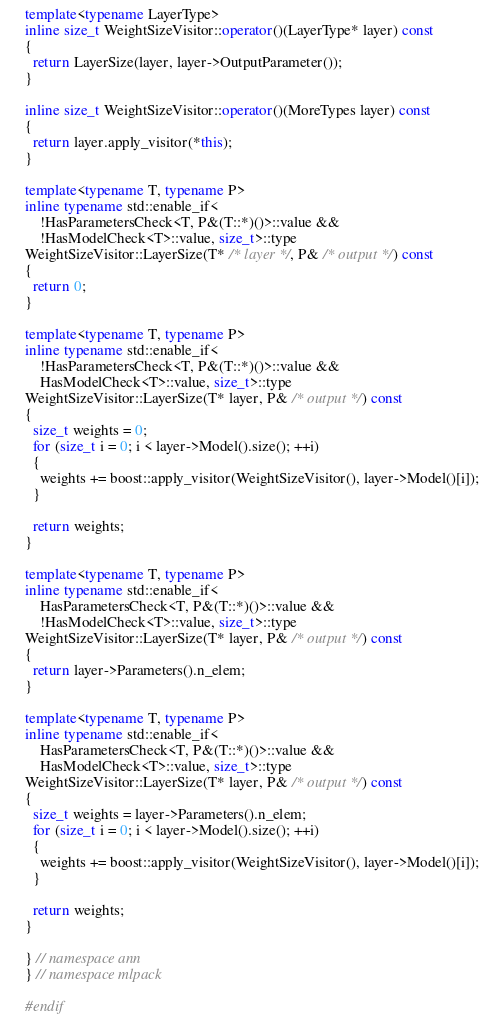<code> <loc_0><loc_0><loc_500><loc_500><_C++_>template<typename LayerType>
inline size_t WeightSizeVisitor::operator()(LayerType* layer) const
{
  return LayerSize(layer, layer->OutputParameter());
}

inline size_t WeightSizeVisitor::operator()(MoreTypes layer) const
{
  return layer.apply_visitor(*this);
}

template<typename T, typename P>
inline typename std::enable_if<
    !HasParametersCheck<T, P&(T::*)()>::value &&
    !HasModelCheck<T>::value, size_t>::type
WeightSizeVisitor::LayerSize(T* /* layer */, P& /* output */) const
{
  return 0;
}

template<typename T, typename P>
inline typename std::enable_if<
    !HasParametersCheck<T, P&(T::*)()>::value &&
    HasModelCheck<T>::value, size_t>::type
WeightSizeVisitor::LayerSize(T* layer, P& /* output */) const
{
  size_t weights = 0;
  for (size_t i = 0; i < layer->Model().size(); ++i)
  {
    weights += boost::apply_visitor(WeightSizeVisitor(), layer->Model()[i]);
  }

  return weights;
}

template<typename T, typename P>
inline typename std::enable_if<
    HasParametersCheck<T, P&(T::*)()>::value &&
    !HasModelCheck<T>::value, size_t>::type
WeightSizeVisitor::LayerSize(T* layer, P& /* output */) const
{
  return layer->Parameters().n_elem;
}

template<typename T, typename P>
inline typename std::enable_if<
    HasParametersCheck<T, P&(T::*)()>::value &&
    HasModelCheck<T>::value, size_t>::type
WeightSizeVisitor::LayerSize(T* layer, P& /* output */) const
{
  size_t weights = layer->Parameters().n_elem;
  for (size_t i = 0; i < layer->Model().size(); ++i)
  {
    weights += boost::apply_visitor(WeightSizeVisitor(), layer->Model()[i]);
  }

  return weights;
}

} // namespace ann
} // namespace mlpack

#endif
</code> 